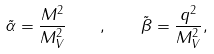Convert formula to latex. <formula><loc_0><loc_0><loc_500><loc_500>\tilde { \alpha } = \frac { M ^ { 2 } } { M _ { V } ^ { 2 } } \quad , \quad \tilde { \beta } = \frac { q ^ { 2 } } { M _ { V } ^ { 2 } } ,</formula> 